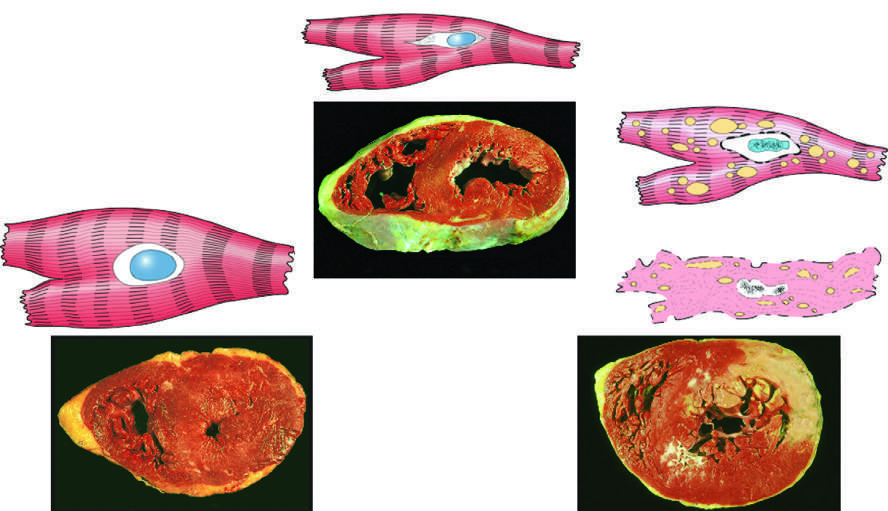how many cm (normal, 1-1.5 cm) is the left ventricular wall thicker than in the example of myocardial hypertrophy lower left?
Answer the question using a single word or phrase. 2 cm 